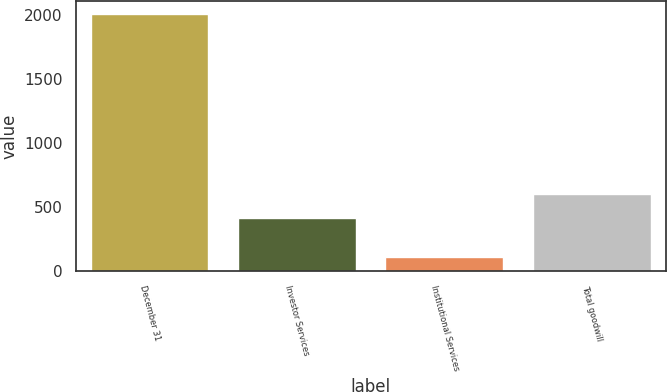Convert chart. <chart><loc_0><loc_0><loc_500><loc_500><bar_chart><fcel>December 31<fcel>Investor Services<fcel>Institutional Services<fcel>Total goodwill<nl><fcel>2009<fcel>416<fcel>112<fcel>605.7<nl></chart> 